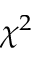<formula> <loc_0><loc_0><loc_500><loc_500>\chi ^ { 2 }</formula> 